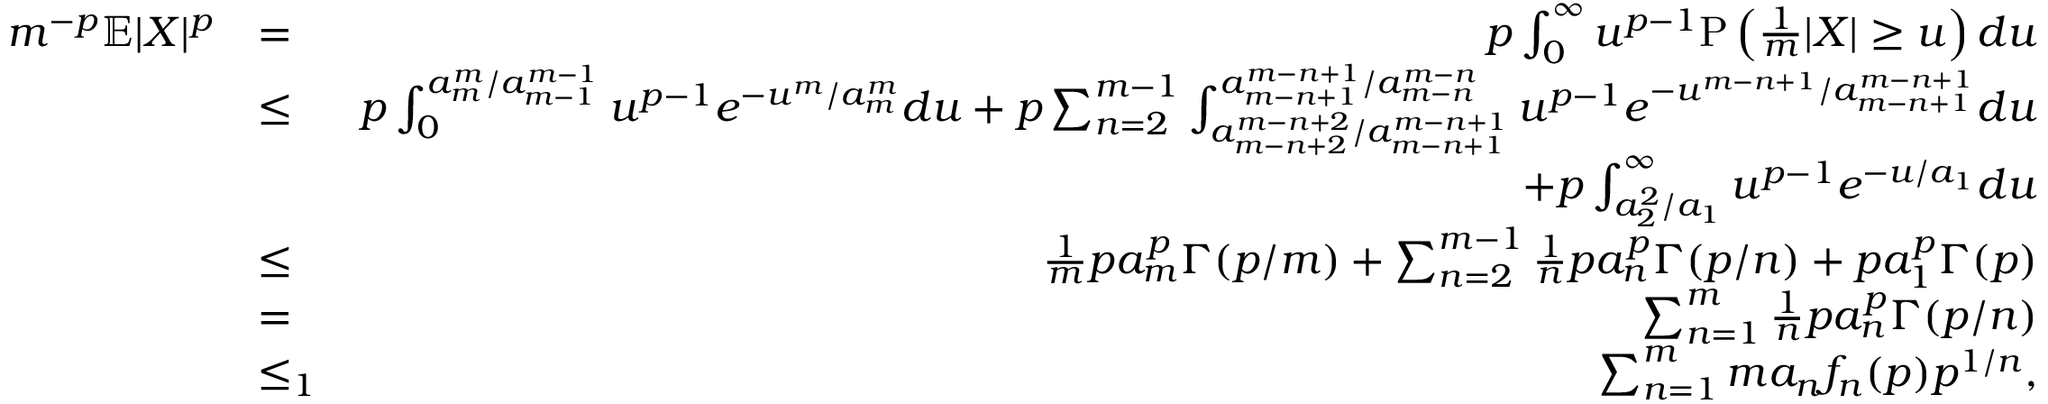<formula> <loc_0><loc_0><loc_500><loc_500>\begin{array} { r l r } { m ^ { - p } \mathbb { E } | X | ^ { p } } & { = } & { p \int _ { 0 } ^ { \infty } u ^ { p - 1 } P \left ( \frac { 1 } { m } | X | \geq u \right ) d u } \\ & { \leq } & { p \int _ { 0 } ^ { a _ { m } ^ { m } / a _ { m - 1 } ^ { m - 1 } } u ^ { p - 1 } e ^ { - u ^ { m } / a _ { m } ^ { m } } d u + p \sum _ { n = 2 } ^ { m - 1 } \int _ { a _ { m - n + 2 } ^ { m - n + 2 } / a _ { m - n + 1 } ^ { m - n + 1 } } ^ { a _ { m - n + 1 } ^ { m - n + 1 } / a _ { m - n } ^ { m - n } } u ^ { p - 1 } e ^ { - u ^ { m - n + 1 } / a _ { m - n + 1 } ^ { m - n + 1 } } d u } \\ & { + p \int _ { a _ { 2 } ^ { 2 } / a _ { 1 } } ^ { \infty } u ^ { p - 1 } e ^ { - u / a _ { 1 } } d u } \\ & { \leq } & { \frac { 1 } { m } p a _ { m } ^ { p } \Gamma ( p / m ) + \sum _ { n = 2 } ^ { m - 1 } \frac { 1 } { n } p a _ { n } ^ { p } \Gamma ( p / n ) + p a _ { 1 } ^ { p } \Gamma ( p ) } \\ & { = } & { \sum _ { n = 1 } ^ { m } \frac { 1 } { n } p a _ { n } ^ { p } \Gamma ( p / n ) } \\ & { \leq _ { 1 } } & { \sum _ { n = 1 } ^ { m } m a _ { n } f _ { n } ( p ) p ^ { 1 / n } , } \end{array}</formula> 